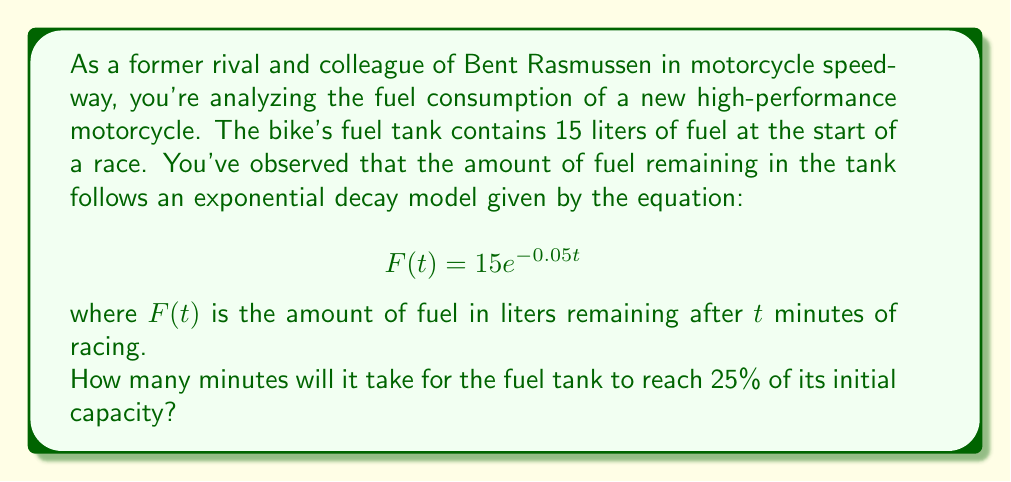Provide a solution to this math problem. To solve this problem, we need to use the given exponential decay model and determine when the fuel reaches 25% of its initial amount. Let's approach this step-by-step:

1) The initial amount of fuel is 15 liters. We want to find when 25% of this remains, which is:

   $15 \cdot 0.25 = 3.75$ liters

2) Now, we can set up an equation using the given model:

   $$3.75 = 15e^{-0.05t}$$

3) To solve for $t$, we first divide both sides by 15:

   $$\frac{3.75}{15} = e^{-0.05t}$$

   $$0.25 = e^{-0.05t}$$

4) Now, we take the natural logarithm of both sides:

   $$\ln(0.25) = \ln(e^{-0.05t})$$

   $$\ln(0.25) = -0.05t$$

5) Solve for $t$ by dividing both sides by -0.05:

   $$t = \frac{\ln(0.25)}{-0.05}$$

6) Calculate the result:

   $$t = \frac{-1.3862943611198906}{-0.05} \approx 27.73$$

Therefore, it will take approximately 27.73 minutes for the fuel tank to reach 25% of its initial capacity.
Answer: 27.73 minutes 